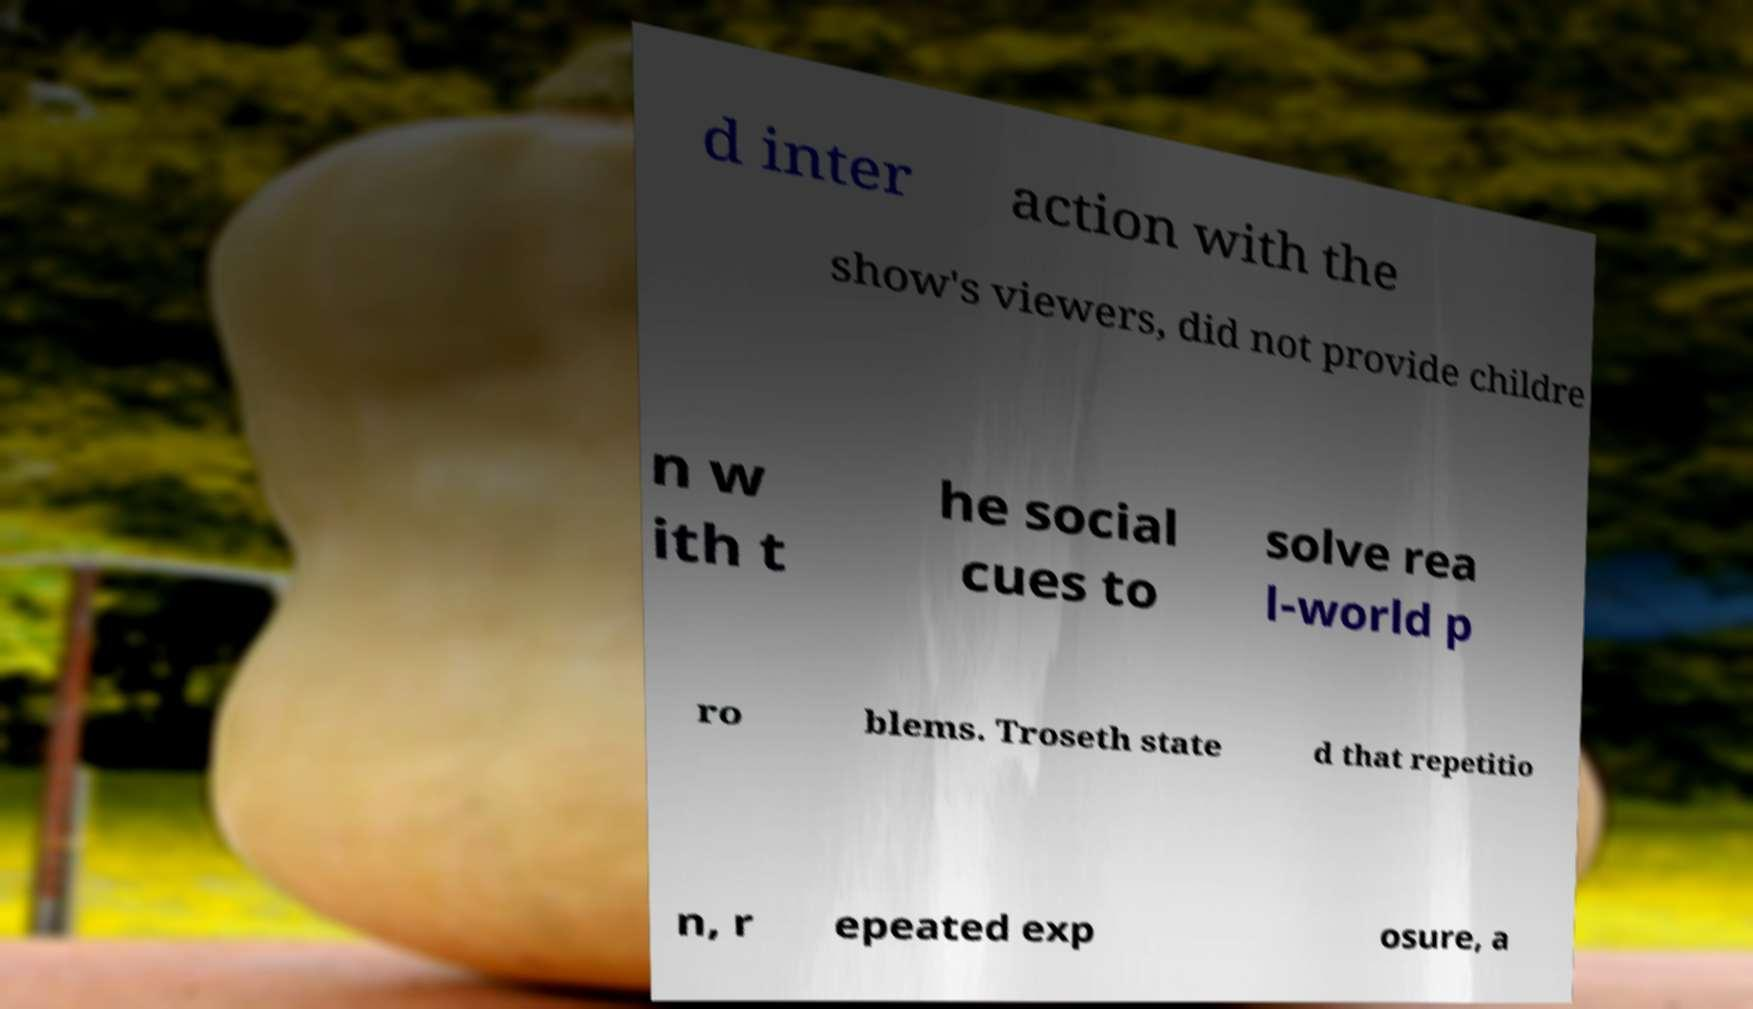For documentation purposes, I need the text within this image transcribed. Could you provide that? d inter action with the show's viewers, did not provide childre n w ith t he social cues to solve rea l-world p ro blems. Troseth state d that repetitio n, r epeated exp osure, a 